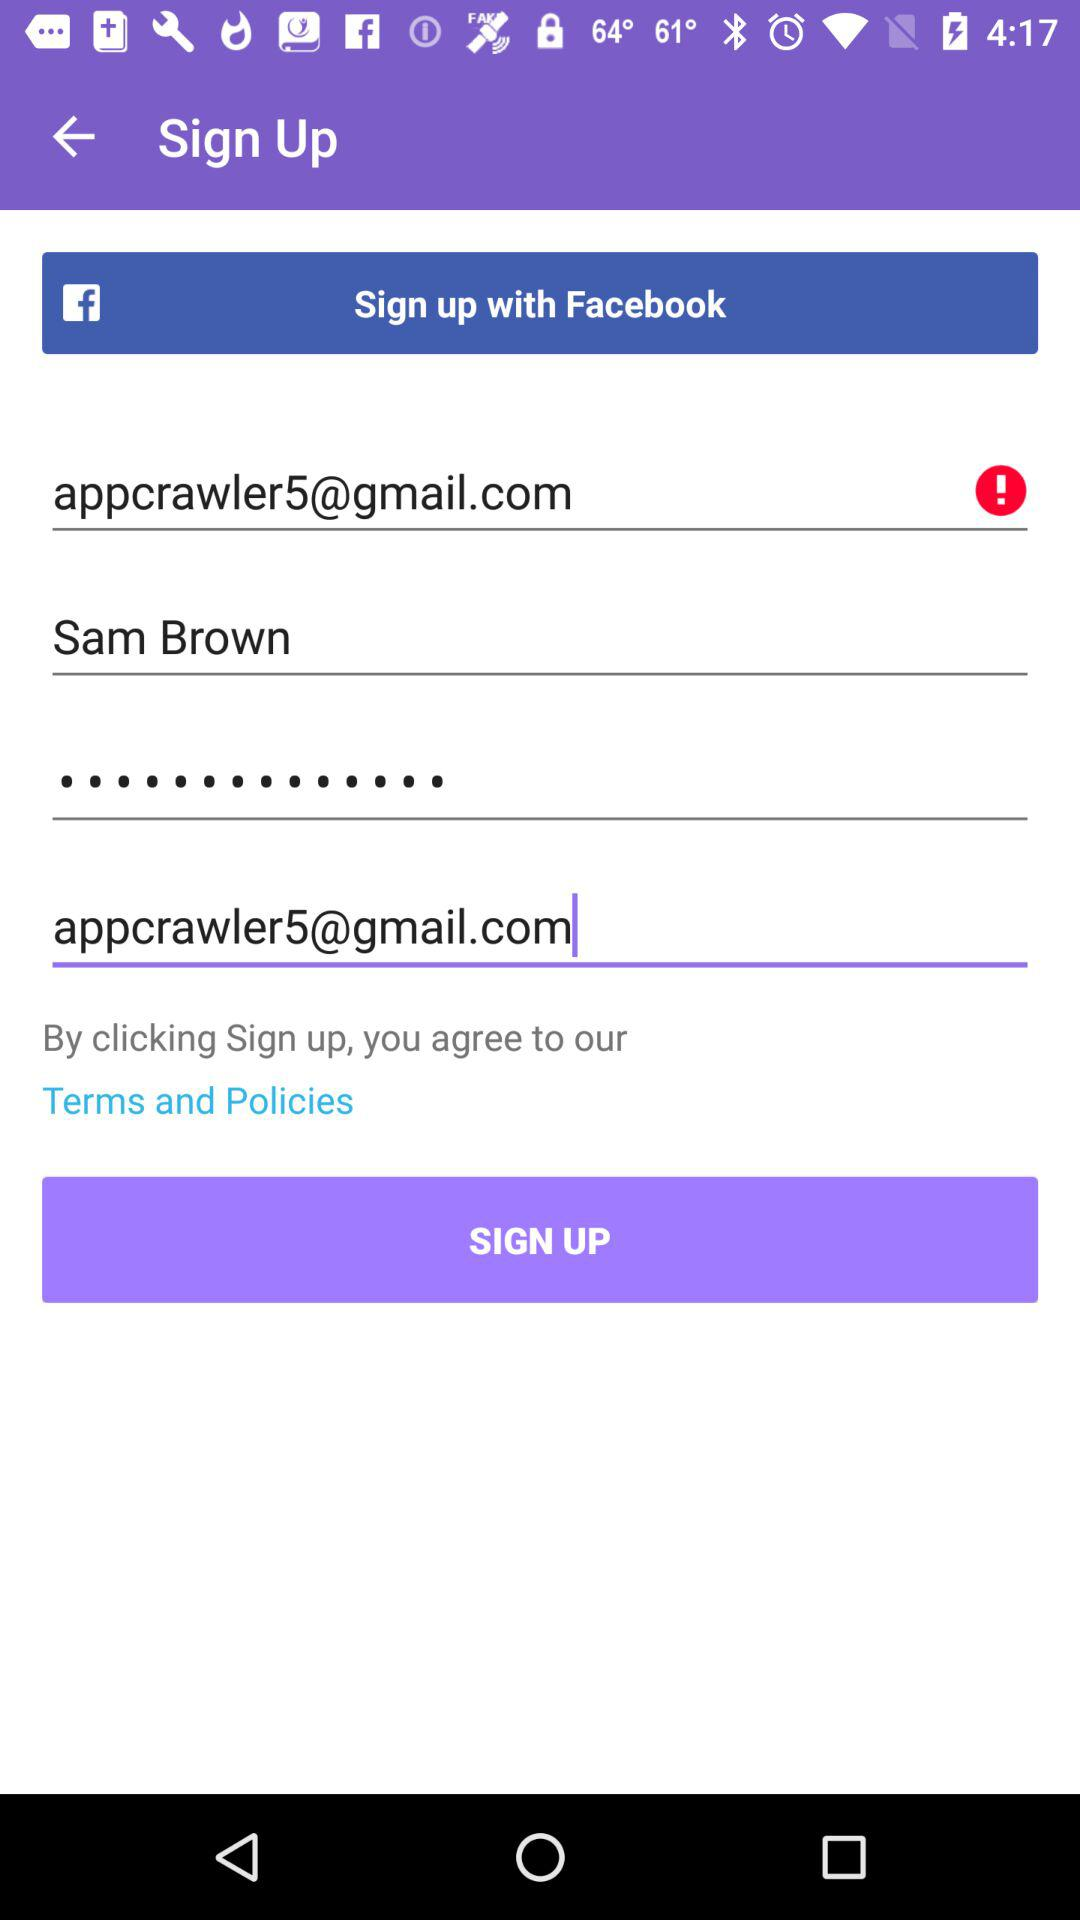What's the user name? The user name is Sam Brown. 